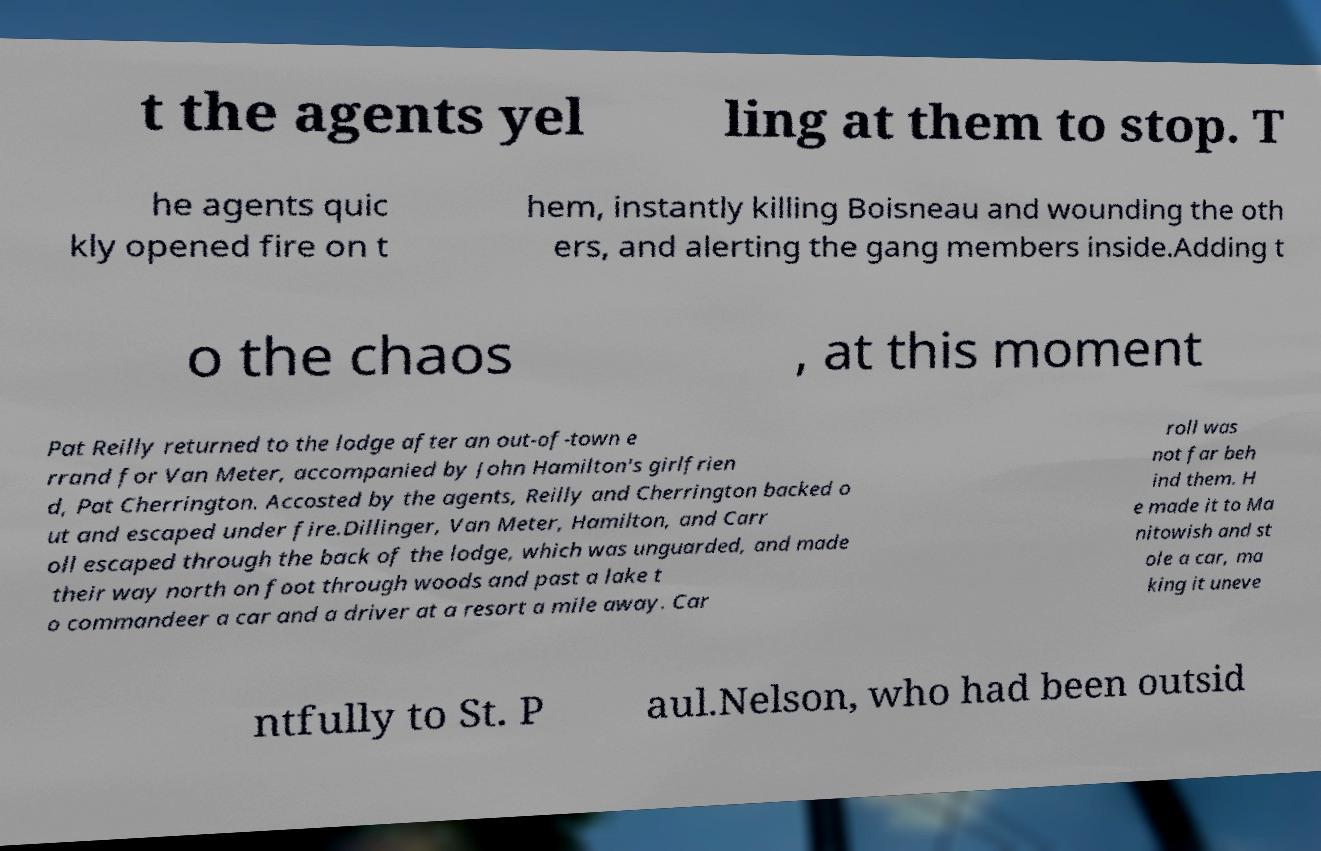Can you accurately transcribe the text from the provided image for me? t the agents yel ling at them to stop. T he agents quic kly opened fire on t hem, instantly killing Boisneau and wounding the oth ers, and alerting the gang members inside.Adding t o the chaos , at this moment Pat Reilly returned to the lodge after an out-of-town e rrand for Van Meter, accompanied by John Hamilton's girlfrien d, Pat Cherrington. Accosted by the agents, Reilly and Cherrington backed o ut and escaped under fire.Dillinger, Van Meter, Hamilton, and Carr oll escaped through the back of the lodge, which was unguarded, and made their way north on foot through woods and past a lake t o commandeer a car and a driver at a resort a mile away. Car roll was not far beh ind them. H e made it to Ma nitowish and st ole a car, ma king it uneve ntfully to St. P aul.Nelson, who had been outsid 